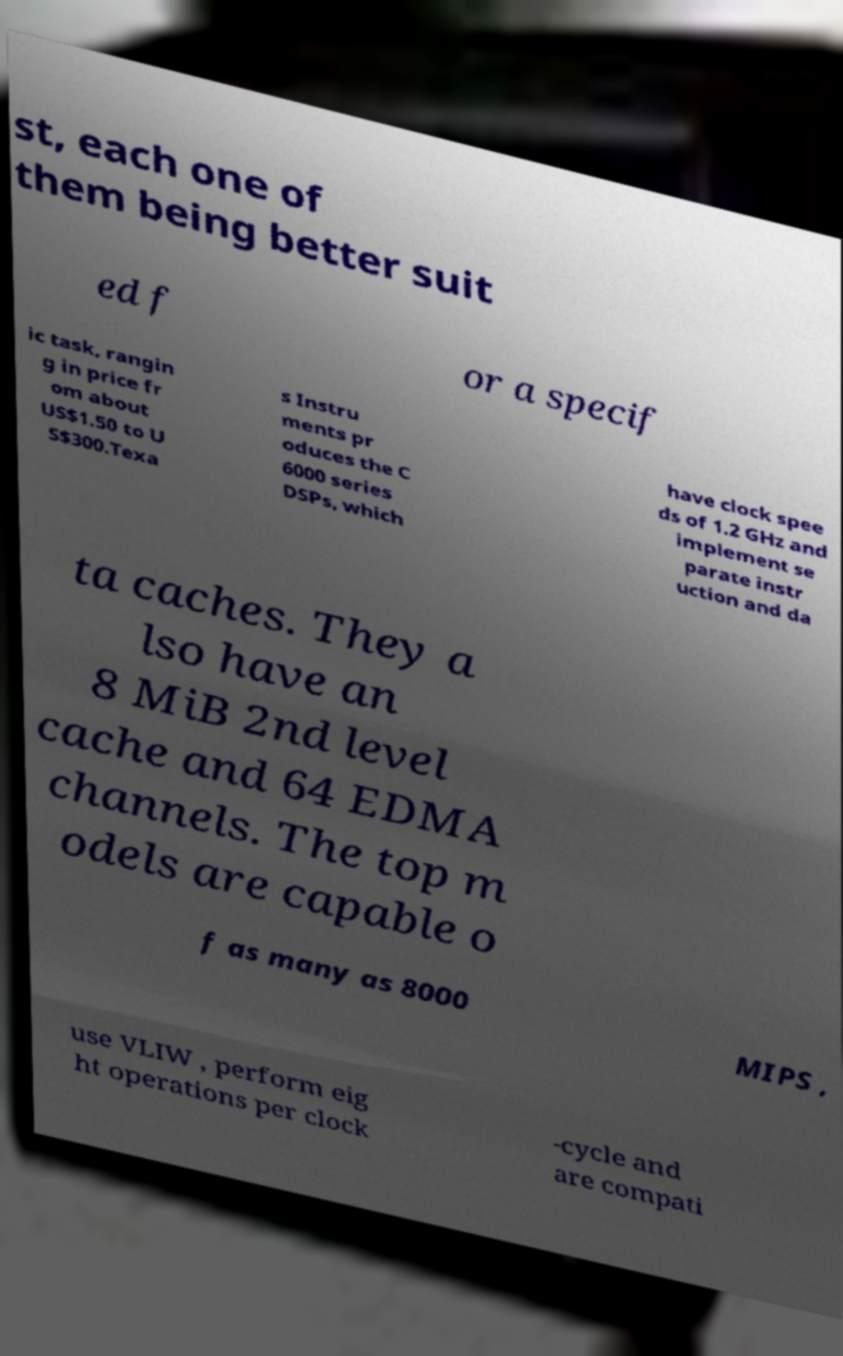For documentation purposes, I need the text within this image transcribed. Could you provide that? st, each one of them being better suit ed f or a specif ic task, rangin g in price fr om about US$1.50 to U S$300.Texa s Instru ments pr oduces the C 6000 series DSPs, which have clock spee ds of 1.2 GHz and implement se parate instr uction and da ta caches. They a lso have an 8 MiB 2nd level cache and 64 EDMA channels. The top m odels are capable o f as many as 8000 MIPS , use VLIW , perform eig ht operations per clock -cycle and are compati 